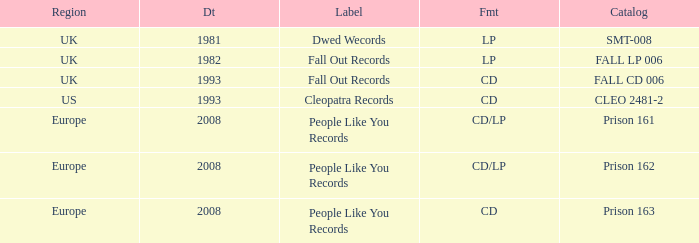Which Format has a Date of 1993, and a Catalog of cleo 2481-2? CD. 